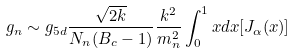<formula> <loc_0><loc_0><loc_500><loc_500>g _ { n } \sim g _ { 5 d } \frac { \sqrt { 2 k } } { N _ { n } ( B _ { c } - 1 ) } \frac { k ^ { 2 } } { m ^ { 2 } _ { n } } \int ^ { 1 } _ { 0 } x d x [ J _ { \alpha } ( x ) ]</formula> 